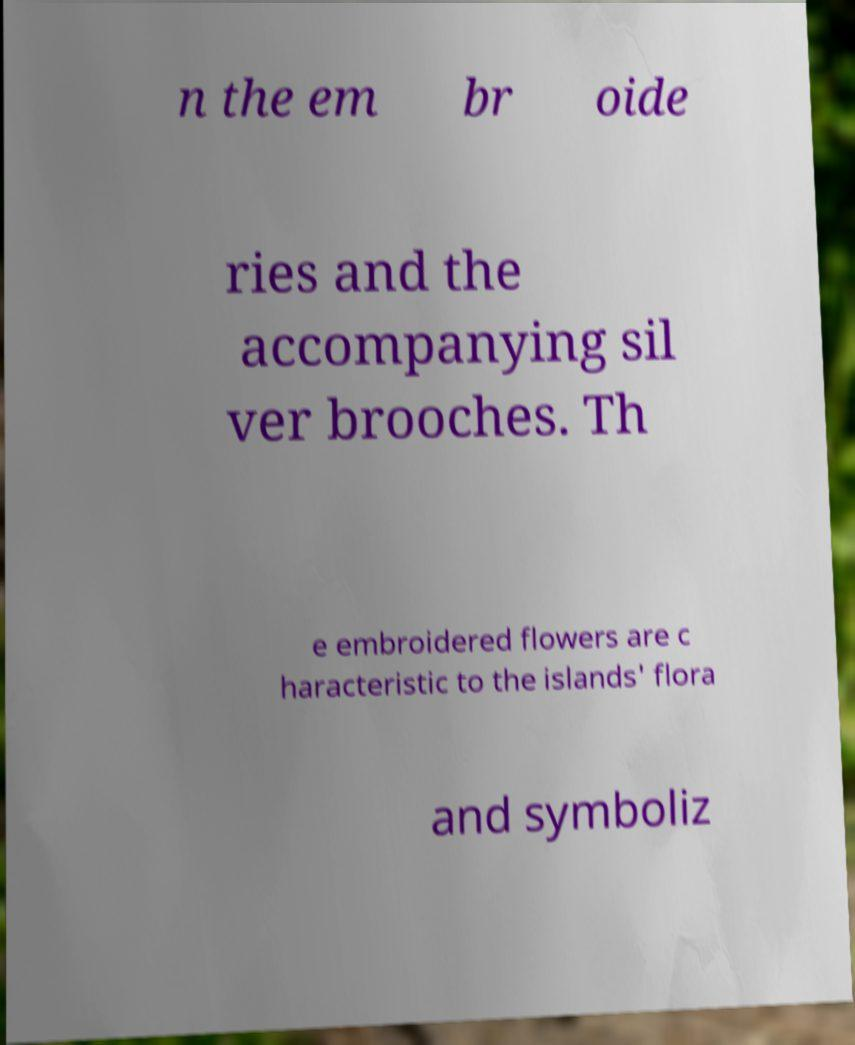What messages or text are displayed in this image? I need them in a readable, typed format. n the em br oide ries and the accompanying sil ver brooches. Th e embroidered flowers are c haracteristic to the islands' flora and symboliz 